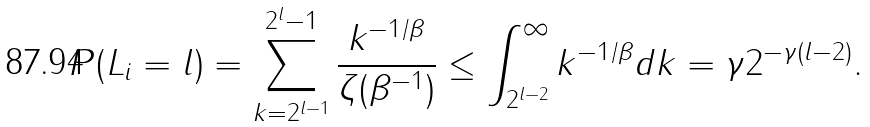<formula> <loc_0><loc_0><loc_500><loc_500>P ( L _ { i } = l ) = \sum _ { k = 2 ^ { l - 1 } } ^ { 2 ^ { l } - 1 } \frac { k ^ { - 1 / \beta } } { \zeta ( \beta ^ { - 1 } ) } \leq \int _ { 2 ^ { l - 2 } } ^ { \infty } k ^ { - 1 / \beta } d k = \gamma 2 ^ { - \gamma ( l - 2 ) } .</formula> 